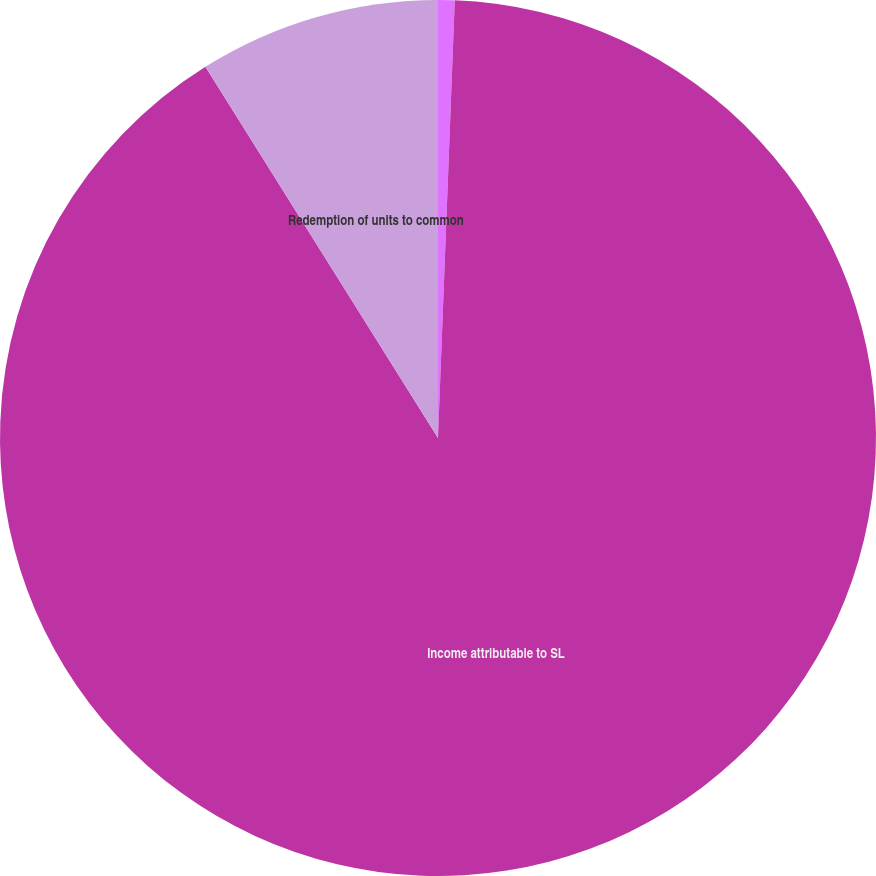Convert chart to OTSL. <chart><loc_0><loc_0><loc_500><loc_500><pie_chart><fcel>NUMERATOR (Income)<fcel>Income attributable to SL<fcel>Redemption of units to common<nl><fcel>0.61%<fcel>90.48%<fcel>8.91%<nl></chart> 